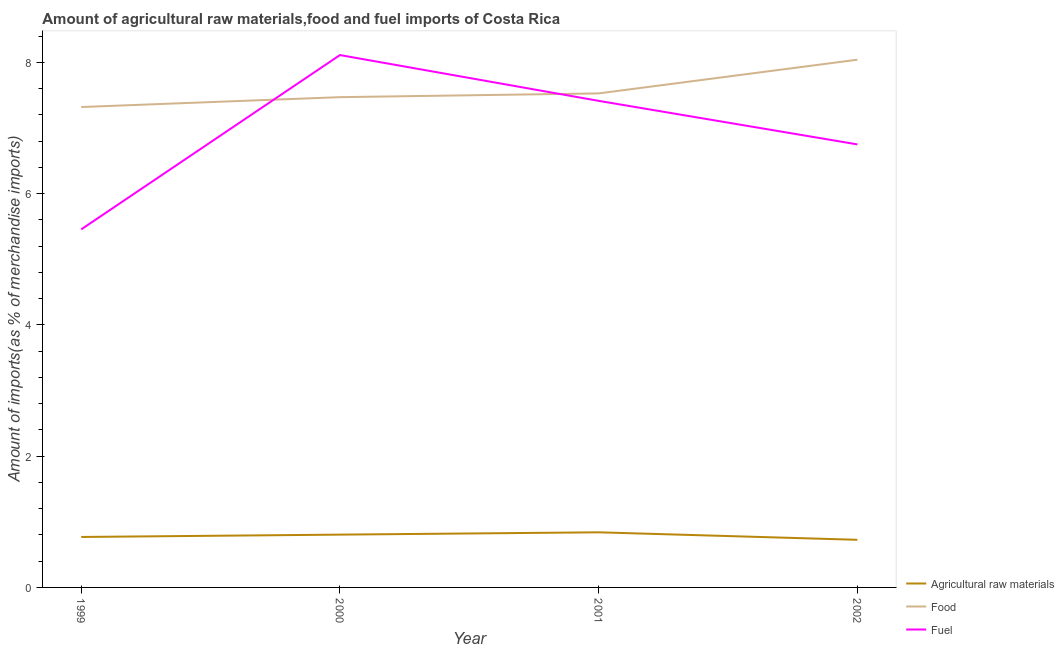Does the line corresponding to percentage of fuel imports intersect with the line corresponding to percentage of food imports?
Offer a terse response. Yes. Is the number of lines equal to the number of legend labels?
Make the answer very short. Yes. What is the percentage of fuel imports in 2002?
Your answer should be compact. 6.75. Across all years, what is the maximum percentage of fuel imports?
Provide a short and direct response. 8.11. Across all years, what is the minimum percentage of fuel imports?
Your response must be concise. 5.45. In which year was the percentage of food imports maximum?
Keep it short and to the point. 2002. In which year was the percentage of food imports minimum?
Your answer should be very brief. 1999. What is the total percentage of fuel imports in the graph?
Keep it short and to the point. 27.72. What is the difference between the percentage of raw materials imports in 1999 and that in 2000?
Your answer should be very brief. -0.04. What is the difference between the percentage of raw materials imports in 2002 and the percentage of fuel imports in 2000?
Offer a very short reply. -7.38. What is the average percentage of fuel imports per year?
Your answer should be very brief. 6.93. In the year 2000, what is the difference between the percentage of food imports and percentage of raw materials imports?
Provide a short and direct response. 6.66. What is the ratio of the percentage of food imports in 1999 to that in 2002?
Offer a terse response. 0.91. What is the difference between the highest and the second highest percentage of fuel imports?
Make the answer very short. 0.7. What is the difference between the highest and the lowest percentage of raw materials imports?
Offer a very short reply. 0.11. In how many years, is the percentage of fuel imports greater than the average percentage of fuel imports taken over all years?
Offer a very short reply. 2. Is it the case that in every year, the sum of the percentage of raw materials imports and percentage of food imports is greater than the percentage of fuel imports?
Your answer should be compact. Yes. Does the percentage of fuel imports monotonically increase over the years?
Offer a terse response. No. Is the percentage of raw materials imports strictly greater than the percentage of food imports over the years?
Give a very brief answer. No. Is the percentage of raw materials imports strictly less than the percentage of fuel imports over the years?
Your answer should be compact. Yes. How are the legend labels stacked?
Your answer should be very brief. Vertical. What is the title of the graph?
Your answer should be very brief. Amount of agricultural raw materials,food and fuel imports of Costa Rica. Does "Infant(male)" appear as one of the legend labels in the graph?
Your response must be concise. No. What is the label or title of the Y-axis?
Your answer should be compact. Amount of imports(as % of merchandise imports). What is the Amount of imports(as % of merchandise imports) in Agricultural raw materials in 1999?
Keep it short and to the point. 0.77. What is the Amount of imports(as % of merchandise imports) of Food in 1999?
Provide a short and direct response. 7.32. What is the Amount of imports(as % of merchandise imports) of Fuel in 1999?
Offer a terse response. 5.45. What is the Amount of imports(as % of merchandise imports) of Agricultural raw materials in 2000?
Give a very brief answer. 0.8. What is the Amount of imports(as % of merchandise imports) of Food in 2000?
Your answer should be compact. 7.47. What is the Amount of imports(as % of merchandise imports) in Fuel in 2000?
Your response must be concise. 8.11. What is the Amount of imports(as % of merchandise imports) of Agricultural raw materials in 2001?
Provide a succinct answer. 0.84. What is the Amount of imports(as % of merchandise imports) of Food in 2001?
Provide a short and direct response. 7.53. What is the Amount of imports(as % of merchandise imports) of Fuel in 2001?
Make the answer very short. 7.41. What is the Amount of imports(as % of merchandise imports) of Agricultural raw materials in 2002?
Your answer should be compact. 0.73. What is the Amount of imports(as % of merchandise imports) in Food in 2002?
Your answer should be very brief. 8.04. What is the Amount of imports(as % of merchandise imports) of Fuel in 2002?
Make the answer very short. 6.75. Across all years, what is the maximum Amount of imports(as % of merchandise imports) in Agricultural raw materials?
Your answer should be very brief. 0.84. Across all years, what is the maximum Amount of imports(as % of merchandise imports) of Food?
Give a very brief answer. 8.04. Across all years, what is the maximum Amount of imports(as % of merchandise imports) in Fuel?
Keep it short and to the point. 8.11. Across all years, what is the minimum Amount of imports(as % of merchandise imports) of Agricultural raw materials?
Offer a terse response. 0.73. Across all years, what is the minimum Amount of imports(as % of merchandise imports) in Food?
Ensure brevity in your answer.  7.32. Across all years, what is the minimum Amount of imports(as % of merchandise imports) of Fuel?
Your answer should be compact. 5.45. What is the total Amount of imports(as % of merchandise imports) in Agricultural raw materials in the graph?
Your answer should be compact. 3.14. What is the total Amount of imports(as % of merchandise imports) of Food in the graph?
Make the answer very short. 30.35. What is the total Amount of imports(as % of merchandise imports) in Fuel in the graph?
Give a very brief answer. 27.72. What is the difference between the Amount of imports(as % of merchandise imports) in Agricultural raw materials in 1999 and that in 2000?
Ensure brevity in your answer.  -0.04. What is the difference between the Amount of imports(as % of merchandise imports) of Food in 1999 and that in 2000?
Provide a succinct answer. -0.15. What is the difference between the Amount of imports(as % of merchandise imports) in Fuel in 1999 and that in 2000?
Offer a very short reply. -2.66. What is the difference between the Amount of imports(as % of merchandise imports) in Agricultural raw materials in 1999 and that in 2001?
Your response must be concise. -0.07. What is the difference between the Amount of imports(as % of merchandise imports) in Food in 1999 and that in 2001?
Give a very brief answer. -0.21. What is the difference between the Amount of imports(as % of merchandise imports) of Fuel in 1999 and that in 2001?
Your answer should be compact. -1.96. What is the difference between the Amount of imports(as % of merchandise imports) in Agricultural raw materials in 1999 and that in 2002?
Give a very brief answer. 0.04. What is the difference between the Amount of imports(as % of merchandise imports) in Food in 1999 and that in 2002?
Provide a short and direct response. -0.72. What is the difference between the Amount of imports(as % of merchandise imports) of Fuel in 1999 and that in 2002?
Offer a very short reply. -1.29. What is the difference between the Amount of imports(as % of merchandise imports) of Agricultural raw materials in 2000 and that in 2001?
Ensure brevity in your answer.  -0.04. What is the difference between the Amount of imports(as % of merchandise imports) of Food in 2000 and that in 2001?
Provide a succinct answer. -0.06. What is the difference between the Amount of imports(as % of merchandise imports) in Fuel in 2000 and that in 2001?
Ensure brevity in your answer.  0.7. What is the difference between the Amount of imports(as % of merchandise imports) in Agricultural raw materials in 2000 and that in 2002?
Provide a short and direct response. 0.08. What is the difference between the Amount of imports(as % of merchandise imports) in Food in 2000 and that in 2002?
Your answer should be compact. -0.57. What is the difference between the Amount of imports(as % of merchandise imports) in Fuel in 2000 and that in 2002?
Provide a short and direct response. 1.36. What is the difference between the Amount of imports(as % of merchandise imports) of Agricultural raw materials in 2001 and that in 2002?
Your answer should be compact. 0.11. What is the difference between the Amount of imports(as % of merchandise imports) of Food in 2001 and that in 2002?
Ensure brevity in your answer.  -0.51. What is the difference between the Amount of imports(as % of merchandise imports) of Fuel in 2001 and that in 2002?
Your answer should be compact. 0.66. What is the difference between the Amount of imports(as % of merchandise imports) in Agricultural raw materials in 1999 and the Amount of imports(as % of merchandise imports) in Food in 2000?
Ensure brevity in your answer.  -6.7. What is the difference between the Amount of imports(as % of merchandise imports) in Agricultural raw materials in 1999 and the Amount of imports(as % of merchandise imports) in Fuel in 2000?
Your response must be concise. -7.34. What is the difference between the Amount of imports(as % of merchandise imports) in Food in 1999 and the Amount of imports(as % of merchandise imports) in Fuel in 2000?
Your answer should be compact. -0.79. What is the difference between the Amount of imports(as % of merchandise imports) in Agricultural raw materials in 1999 and the Amount of imports(as % of merchandise imports) in Food in 2001?
Your response must be concise. -6.76. What is the difference between the Amount of imports(as % of merchandise imports) of Agricultural raw materials in 1999 and the Amount of imports(as % of merchandise imports) of Fuel in 2001?
Ensure brevity in your answer.  -6.64. What is the difference between the Amount of imports(as % of merchandise imports) of Food in 1999 and the Amount of imports(as % of merchandise imports) of Fuel in 2001?
Your response must be concise. -0.09. What is the difference between the Amount of imports(as % of merchandise imports) in Agricultural raw materials in 1999 and the Amount of imports(as % of merchandise imports) in Food in 2002?
Your answer should be compact. -7.27. What is the difference between the Amount of imports(as % of merchandise imports) of Agricultural raw materials in 1999 and the Amount of imports(as % of merchandise imports) of Fuel in 2002?
Provide a succinct answer. -5.98. What is the difference between the Amount of imports(as % of merchandise imports) in Food in 1999 and the Amount of imports(as % of merchandise imports) in Fuel in 2002?
Offer a very short reply. 0.57. What is the difference between the Amount of imports(as % of merchandise imports) of Agricultural raw materials in 2000 and the Amount of imports(as % of merchandise imports) of Food in 2001?
Offer a terse response. -6.72. What is the difference between the Amount of imports(as % of merchandise imports) of Agricultural raw materials in 2000 and the Amount of imports(as % of merchandise imports) of Fuel in 2001?
Your answer should be very brief. -6.61. What is the difference between the Amount of imports(as % of merchandise imports) of Food in 2000 and the Amount of imports(as % of merchandise imports) of Fuel in 2001?
Provide a short and direct response. 0.06. What is the difference between the Amount of imports(as % of merchandise imports) of Agricultural raw materials in 2000 and the Amount of imports(as % of merchandise imports) of Food in 2002?
Offer a very short reply. -7.23. What is the difference between the Amount of imports(as % of merchandise imports) in Agricultural raw materials in 2000 and the Amount of imports(as % of merchandise imports) in Fuel in 2002?
Your answer should be compact. -5.94. What is the difference between the Amount of imports(as % of merchandise imports) in Food in 2000 and the Amount of imports(as % of merchandise imports) in Fuel in 2002?
Provide a succinct answer. 0.72. What is the difference between the Amount of imports(as % of merchandise imports) of Agricultural raw materials in 2001 and the Amount of imports(as % of merchandise imports) of Food in 2002?
Offer a very short reply. -7.2. What is the difference between the Amount of imports(as % of merchandise imports) in Agricultural raw materials in 2001 and the Amount of imports(as % of merchandise imports) in Fuel in 2002?
Provide a succinct answer. -5.91. What is the difference between the Amount of imports(as % of merchandise imports) of Food in 2001 and the Amount of imports(as % of merchandise imports) of Fuel in 2002?
Your answer should be very brief. 0.78. What is the average Amount of imports(as % of merchandise imports) of Agricultural raw materials per year?
Give a very brief answer. 0.78. What is the average Amount of imports(as % of merchandise imports) of Food per year?
Your answer should be compact. 7.59. What is the average Amount of imports(as % of merchandise imports) of Fuel per year?
Make the answer very short. 6.93. In the year 1999, what is the difference between the Amount of imports(as % of merchandise imports) in Agricultural raw materials and Amount of imports(as % of merchandise imports) in Food?
Provide a succinct answer. -6.55. In the year 1999, what is the difference between the Amount of imports(as % of merchandise imports) of Agricultural raw materials and Amount of imports(as % of merchandise imports) of Fuel?
Your answer should be very brief. -4.69. In the year 1999, what is the difference between the Amount of imports(as % of merchandise imports) of Food and Amount of imports(as % of merchandise imports) of Fuel?
Your answer should be very brief. 1.86. In the year 2000, what is the difference between the Amount of imports(as % of merchandise imports) in Agricultural raw materials and Amount of imports(as % of merchandise imports) in Food?
Keep it short and to the point. -6.66. In the year 2000, what is the difference between the Amount of imports(as % of merchandise imports) in Agricultural raw materials and Amount of imports(as % of merchandise imports) in Fuel?
Offer a very short reply. -7.31. In the year 2000, what is the difference between the Amount of imports(as % of merchandise imports) of Food and Amount of imports(as % of merchandise imports) of Fuel?
Offer a very short reply. -0.64. In the year 2001, what is the difference between the Amount of imports(as % of merchandise imports) of Agricultural raw materials and Amount of imports(as % of merchandise imports) of Food?
Keep it short and to the point. -6.69. In the year 2001, what is the difference between the Amount of imports(as % of merchandise imports) of Agricultural raw materials and Amount of imports(as % of merchandise imports) of Fuel?
Your response must be concise. -6.57. In the year 2001, what is the difference between the Amount of imports(as % of merchandise imports) of Food and Amount of imports(as % of merchandise imports) of Fuel?
Keep it short and to the point. 0.11. In the year 2002, what is the difference between the Amount of imports(as % of merchandise imports) in Agricultural raw materials and Amount of imports(as % of merchandise imports) in Food?
Ensure brevity in your answer.  -7.31. In the year 2002, what is the difference between the Amount of imports(as % of merchandise imports) in Agricultural raw materials and Amount of imports(as % of merchandise imports) in Fuel?
Your answer should be very brief. -6.02. In the year 2002, what is the difference between the Amount of imports(as % of merchandise imports) of Food and Amount of imports(as % of merchandise imports) of Fuel?
Your response must be concise. 1.29. What is the ratio of the Amount of imports(as % of merchandise imports) in Agricultural raw materials in 1999 to that in 2000?
Offer a terse response. 0.96. What is the ratio of the Amount of imports(as % of merchandise imports) in Food in 1999 to that in 2000?
Your answer should be compact. 0.98. What is the ratio of the Amount of imports(as % of merchandise imports) in Fuel in 1999 to that in 2000?
Make the answer very short. 0.67. What is the ratio of the Amount of imports(as % of merchandise imports) in Agricultural raw materials in 1999 to that in 2001?
Your answer should be compact. 0.92. What is the ratio of the Amount of imports(as % of merchandise imports) in Food in 1999 to that in 2001?
Keep it short and to the point. 0.97. What is the ratio of the Amount of imports(as % of merchandise imports) of Fuel in 1999 to that in 2001?
Keep it short and to the point. 0.74. What is the ratio of the Amount of imports(as % of merchandise imports) in Agricultural raw materials in 1999 to that in 2002?
Your answer should be very brief. 1.06. What is the ratio of the Amount of imports(as % of merchandise imports) of Food in 1999 to that in 2002?
Provide a short and direct response. 0.91. What is the ratio of the Amount of imports(as % of merchandise imports) in Fuel in 1999 to that in 2002?
Offer a very short reply. 0.81. What is the ratio of the Amount of imports(as % of merchandise imports) of Agricultural raw materials in 2000 to that in 2001?
Your answer should be compact. 0.96. What is the ratio of the Amount of imports(as % of merchandise imports) of Fuel in 2000 to that in 2001?
Offer a terse response. 1.09. What is the ratio of the Amount of imports(as % of merchandise imports) in Agricultural raw materials in 2000 to that in 2002?
Your answer should be compact. 1.11. What is the ratio of the Amount of imports(as % of merchandise imports) of Food in 2000 to that in 2002?
Provide a succinct answer. 0.93. What is the ratio of the Amount of imports(as % of merchandise imports) of Fuel in 2000 to that in 2002?
Provide a succinct answer. 1.2. What is the ratio of the Amount of imports(as % of merchandise imports) in Agricultural raw materials in 2001 to that in 2002?
Give a very brief answer. 1.16. What is the ratio of the Amount of imports(as % of merchandise imports) in Food in 2001 to that in 2002?
Give a very brief answer. 0.94. What is the ratio of the Amount of imports(as % of merchandise imports) in Fuel in 2001 to that in 2002?
Ensure brevity in your answer.  1.1. What is the difference between the highest and the second highest Amount of imports(as % of merchandise imports) of Agricultural raw materials?
Offer a very short reply. 0.04. What is the difference between the highest and the second highest Amount of imports(as % of merchandise imports) in Food?
Offer a very short reply. 0.51. What is the difference between the highest and the second highest Amount of imports(as % of merchandise imports) of Fuel?
Provide a short and direct response. 0.7. What is the difference between the highest and the lowest Amount of imports(as % of merchandise imports) in Agricultural raw materials?
Keep it short and to the point. 0.11. What is the difference between the highest and the lowest Amount of imports(as % of merchandise imports) in Food?
Offer a terse response. 0.72. What is the difference between the highest and the lowest Amount of imports(as % of merchandise imports) in Fuel?
Your response must be concise. 2.66. 